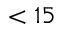<formula> <loc_0><loc_0><loc_500><loc_500>< 1 5</formula> 